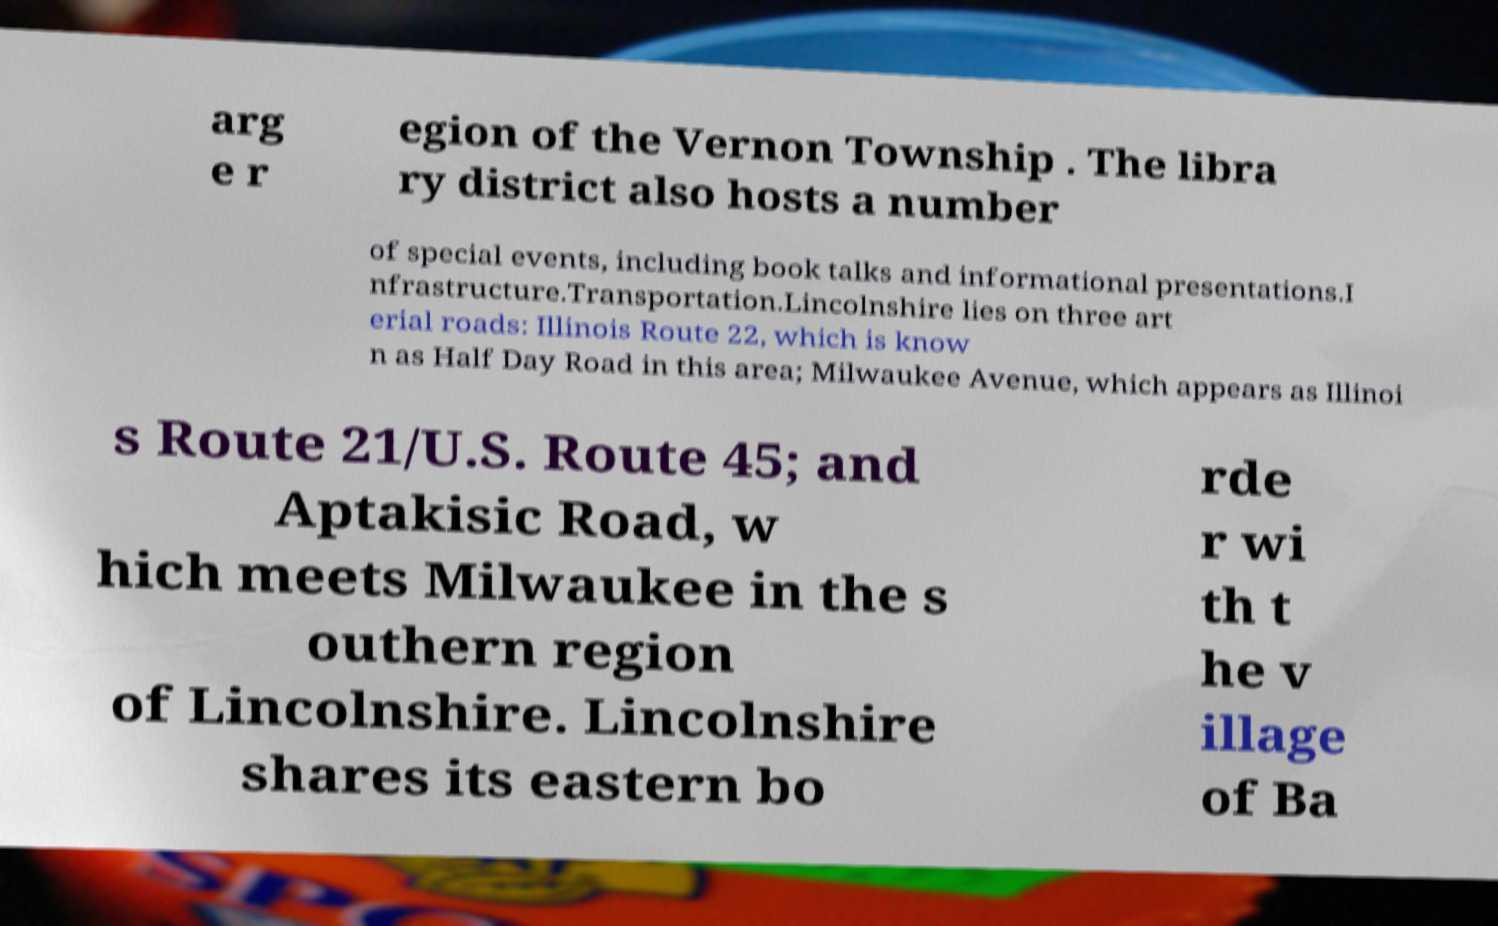Can you accurately transcribe the text from the provided image for me? arg e r egion of the Vernon Township . The libra ry district also hosts a number of special events, including book talks and informational presentations.I nfrastructure.Transportation.Lincolnshire lies on three art erial roads: Illinois Route 22, which is know n as Half Day Road in this area; Milwaukee Avenue, which appears as Illinoi s Route 21/U.S. Route 45; and Aptakisic Road, w hich meets Milwaukee in the s outhern region of Lincolnshire. Lincolnshire shares its eastern bo rde r wi th t he v illage of Ba 